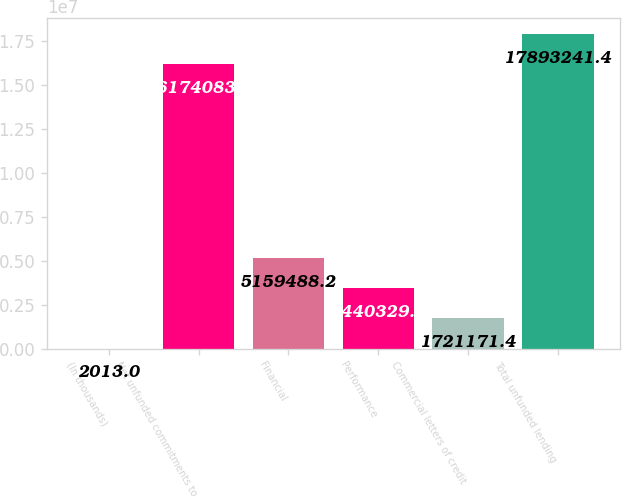<chart> <loc_0><loc_0><loc_500><loc_500><bar_chart><fcel>(In thousands)<fcel>Net unfunded commitments to<fcel>Financial<fcel>Performance<fcel>Commercial letters of credit<fcel>Total unfunded lending<nl><fcel>2013<fcel>1.61741e+07<fcel>5.15949e+06<fcel>3.44033e+06<fcel>1.72117e+06<fcel>1.78932e+07<nl></chart> 